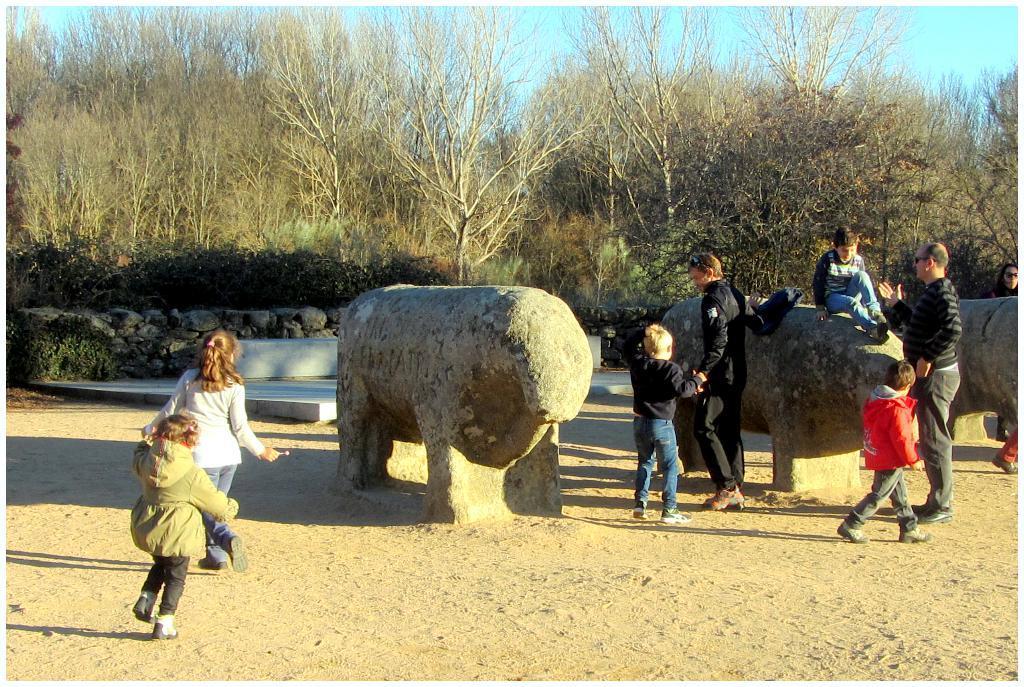Could you give a brief overview of what you see in this image? In the center of the image we can see three solid structures and we can see one person is sitting on one of the solid structures. And we can see a few people are standing and they are in different costumes. Among them, we can see a few people are holding some objects. In the background we can see the sky, trees, plants, stones, sand and a few other objects. 